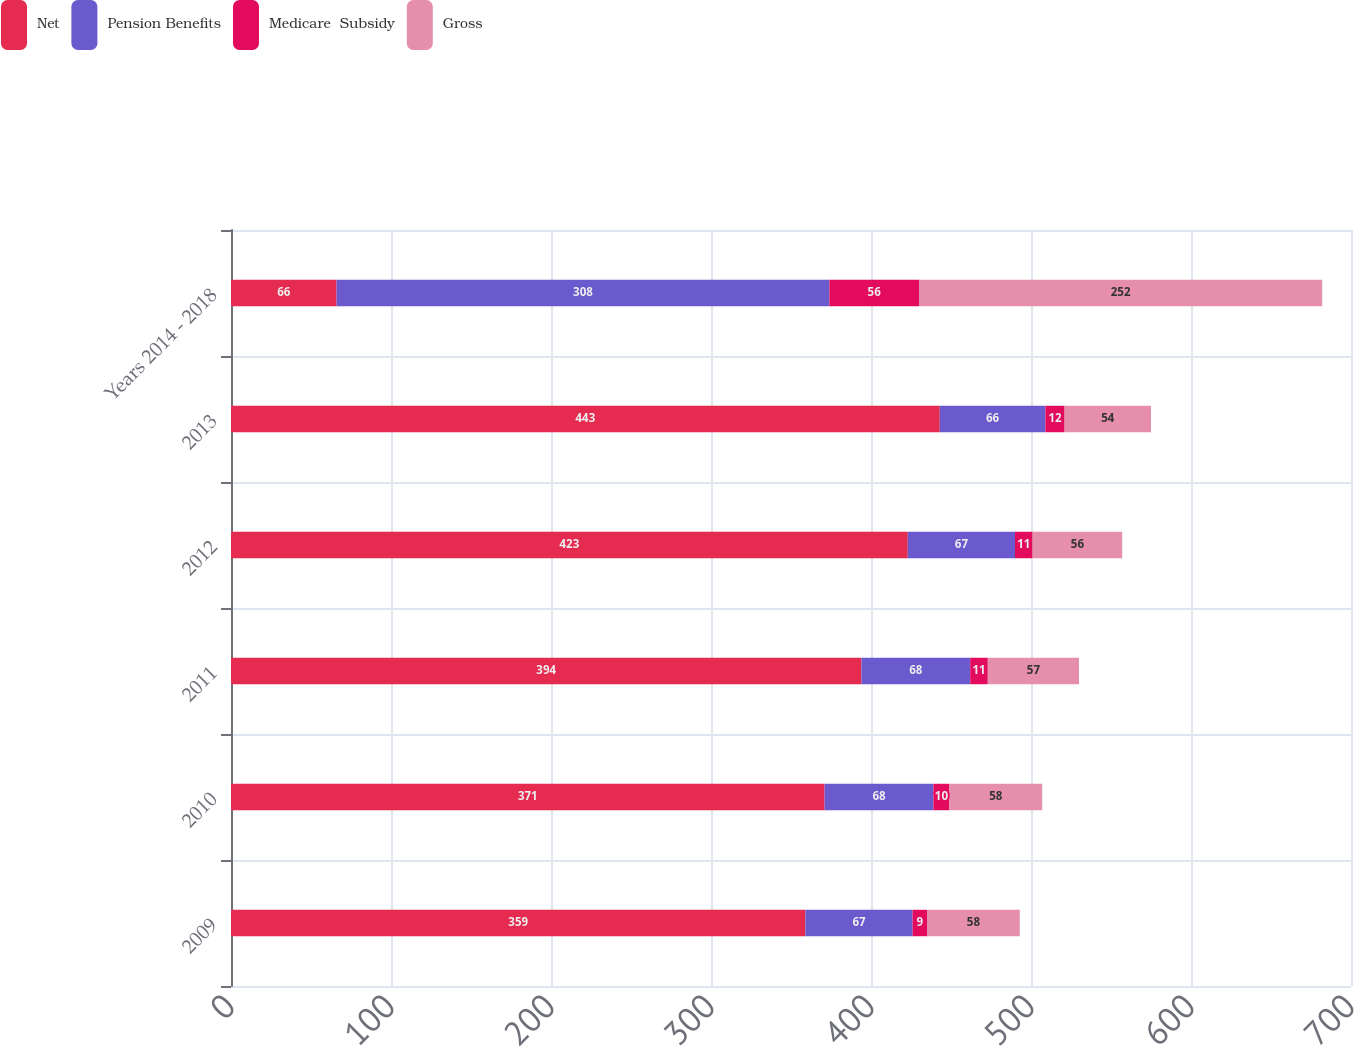Convert chart to OTSL. <chart><loc_0><loc_0><loc_500><loc_500><stacked_bar_chart><ecel><fcel>2009<fcel>2010<fcel>2011<fcel>2012<fcel>2013<fcel>Years 2014 - 2018<nl><fcel>Net<fcel>359<fcel>371<fcel>394<fcel>423<fcel>443<fcel>66<nl><fcel>Pension Benefits<fcel>67<fcel>68<fcel>68<fcel>67<fcel>66<fcel>308<nl><fcel>Medicare  Subsidy<fcel>9<fcel>10<fcel>11<fcel>11<fcel>12<fcel>56<nl><fcel>Gross<fcel>58<fcel>58<fcel>57<fcel>56<fcel>54<fcel>252<nl></chart> 